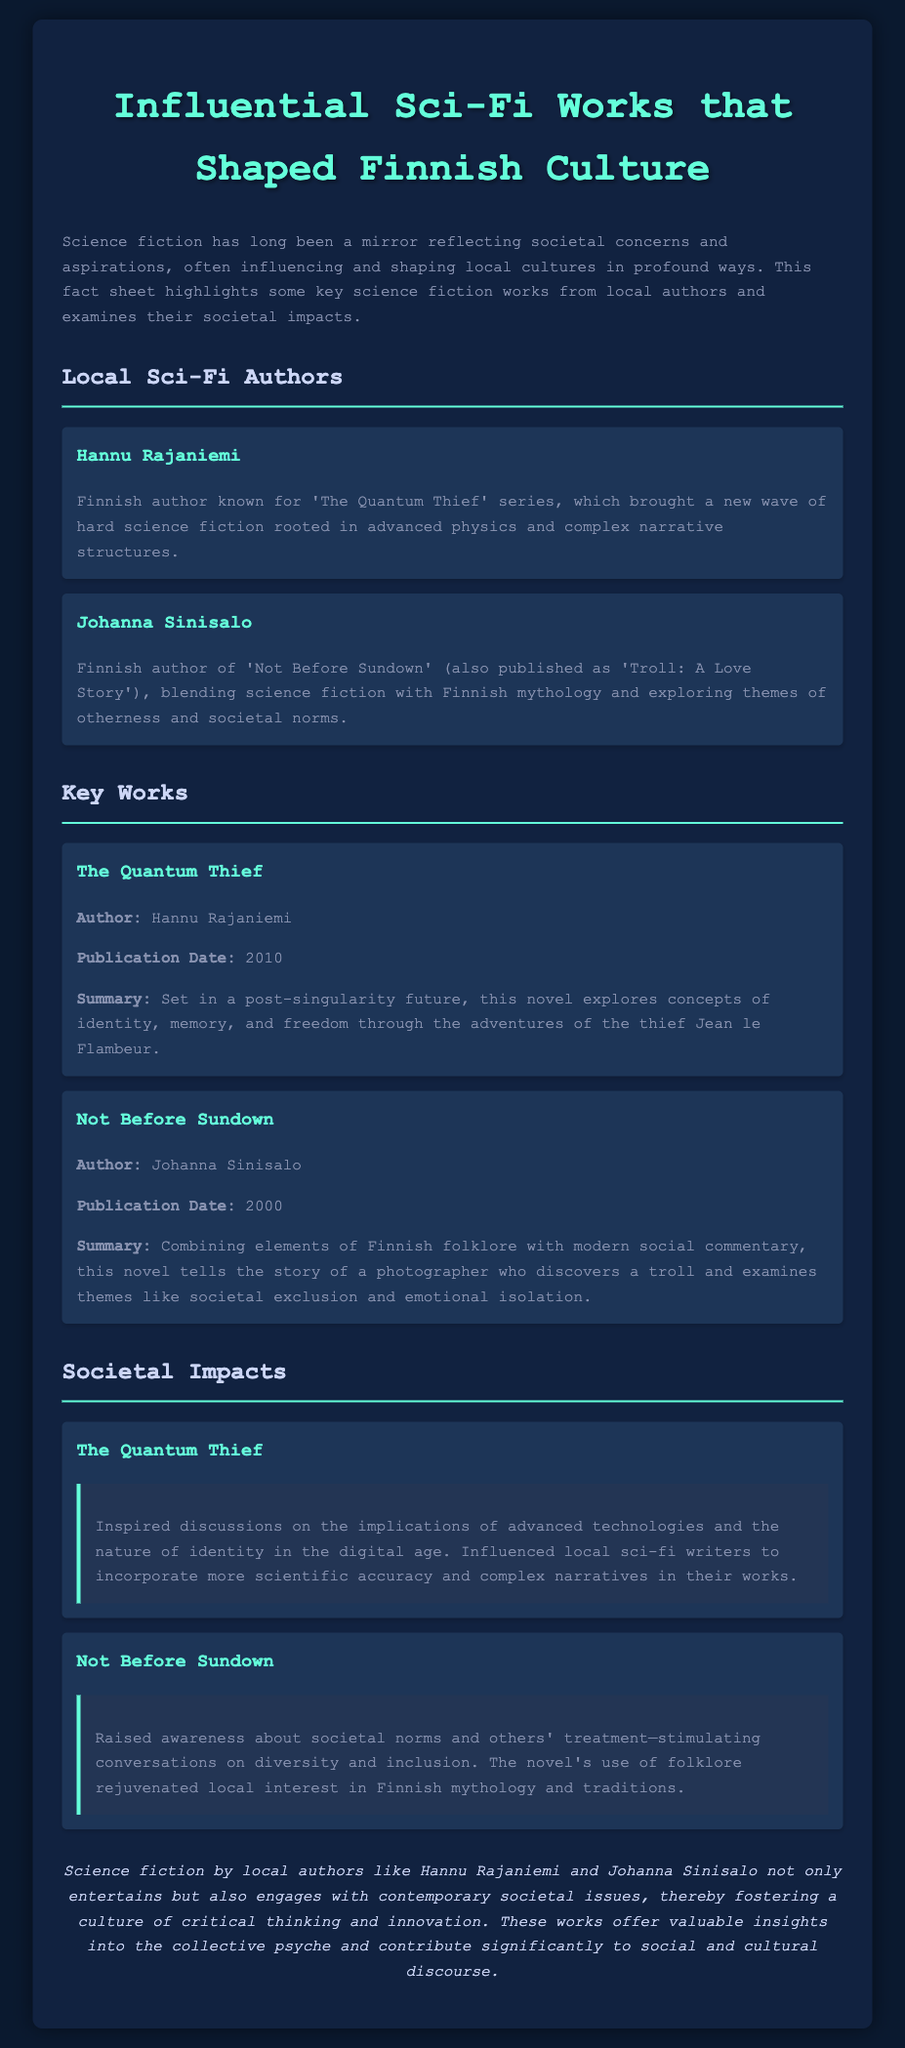what is the name of the author of 'The Quantum Thief'? 'The Quantum Thief' is written by Hannu Rajaniemi.
Answer: Hannu Rajaniemi when was 'Not Before Sundown' published? The publication date for 'Not Before Sundown' is listed as 2000.
Answer: 2000 what are the main themes explored in 'Not Before Sundown'? The themes in 'Not Before Sundown' include societal exclusion and emotional isolation.
Answer: societal exclusion and emotional isolation which Finnish author blends science fiction with mythology? The author who blends science fiction with mythology is Johanna Sinisalo.
Answer: Johanna Sinisalo how did 'The Quantum Thief' influence local sci-fi writers? 'The Quantum Thief' inspired local sci-fi writers to incorporate more scientific accuracy and complex narratives.
Answer: more scientific accuracy and complex narratives what societal issue does 'Not Before Sundown' raise awareness about? The novel raises awareness about diversity and inclusion.
Answer: diversity and inclusion who is the main character in 'The Quantum Thief'? The main character in 'The Quantum Thief' is Jean le Flambeur.
Answer: Jean le Flambeur what genre does 'Not Before Sundown' belong to? 'Not Before Sundown' belongs to the science fiction genre.
Answer: science fiction what impact did 'Not Before Sundown' have on local interest in mythology? The novel rejuvenated local interest in Finnish mythology and traditions.
Answer: rejuvenated local interest in Finnish mythology and traditions 